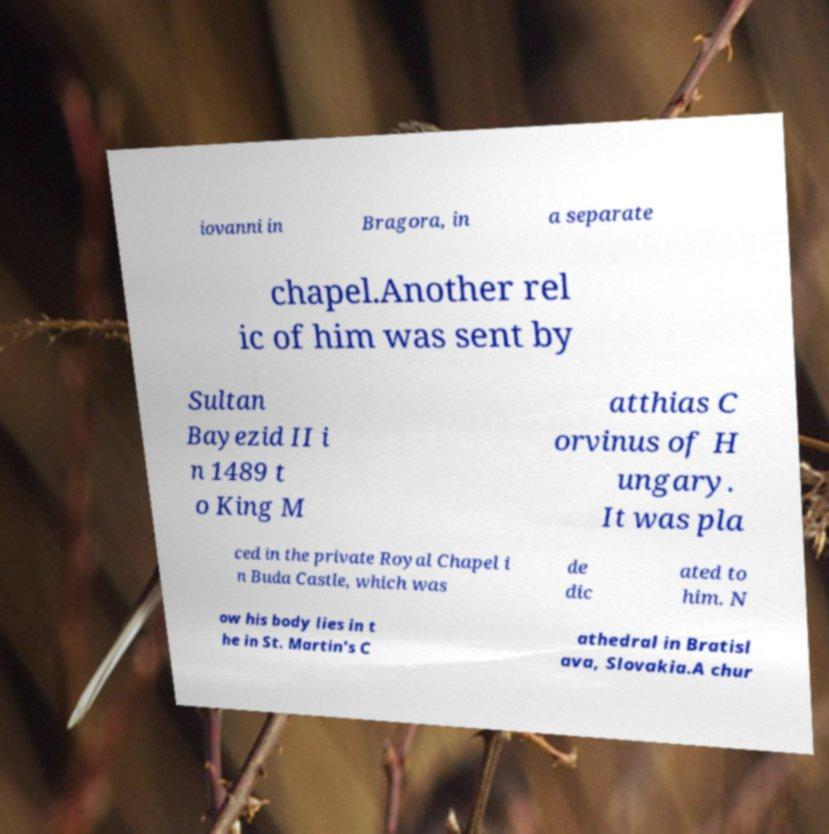What messages or text are displayed in this image? I need them in a readable, typed format. iovanni in Bragora, in a separate chapel.Another rel ic of him was sent by Sultan Bayezid II i n 1489 t o King M atthias C orvinus of H ungary. It was pla ced in the private Royal Chapel i n Buda Castle, which was de dic ated to him. N ow his body lies in t he in St. Martin's C athedral in Bratisl ava, Slovakia.A chur 